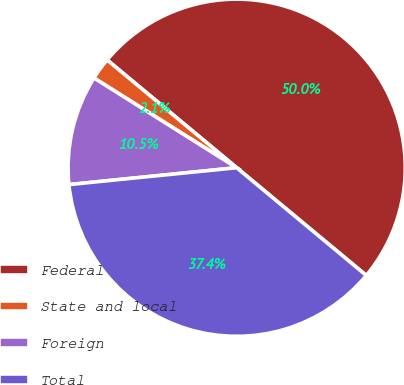Convert chart. <chart><loc_0><loc_0><loc_500><loc_500><pie_chart><fcel>Federal<fcel>State and local<fcel>Foreign<fcel>Total<nl><fcel>50.0%<fcel>2.11%<fcel>10.53%<fcel>37.37%<nl></chart> 